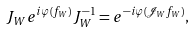Convert formula to latex. <formula><loc_0><loc_0><loc_500><loc_500>J _ { W } e ^ { i \varphi ( f _ { W } ) } J _ { W } ^ { - 1 } = e ^ { - i \varphi ( \mathcal { J } _ { W } f _ { W } ) } ,</formula> 